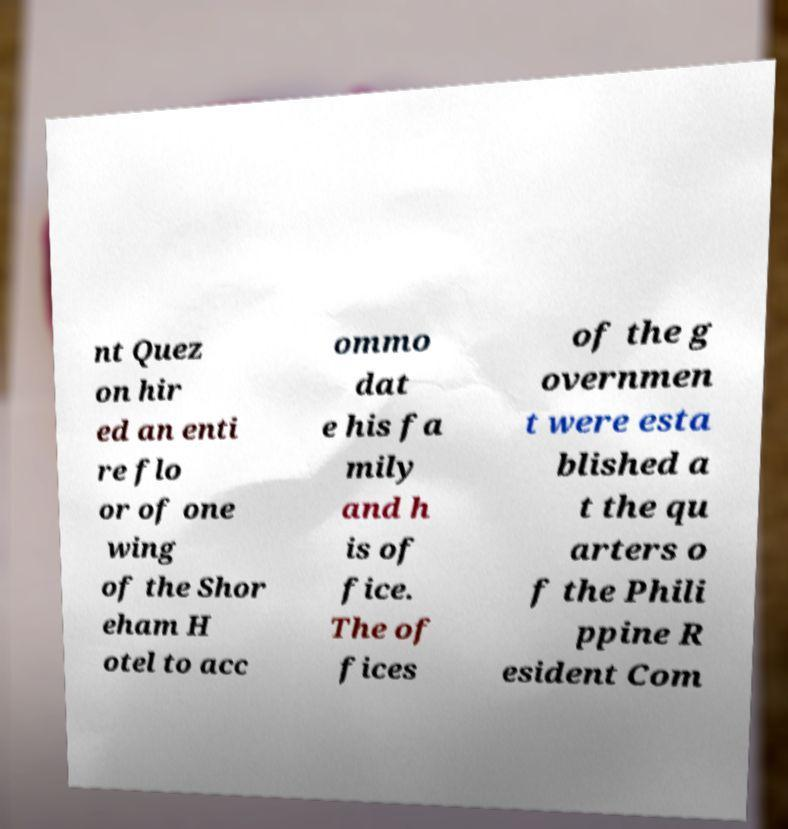Please read and relay the text visible in this image. What does it say? nt Quez on hir ed an enti re flo or of one wing of the Shor eham H otel to acc ommo dat e his fa mily and h is of fice. The of fices of the g overnmen t were esta blished a t the qu arters o f the Phili ppine R esident Com 